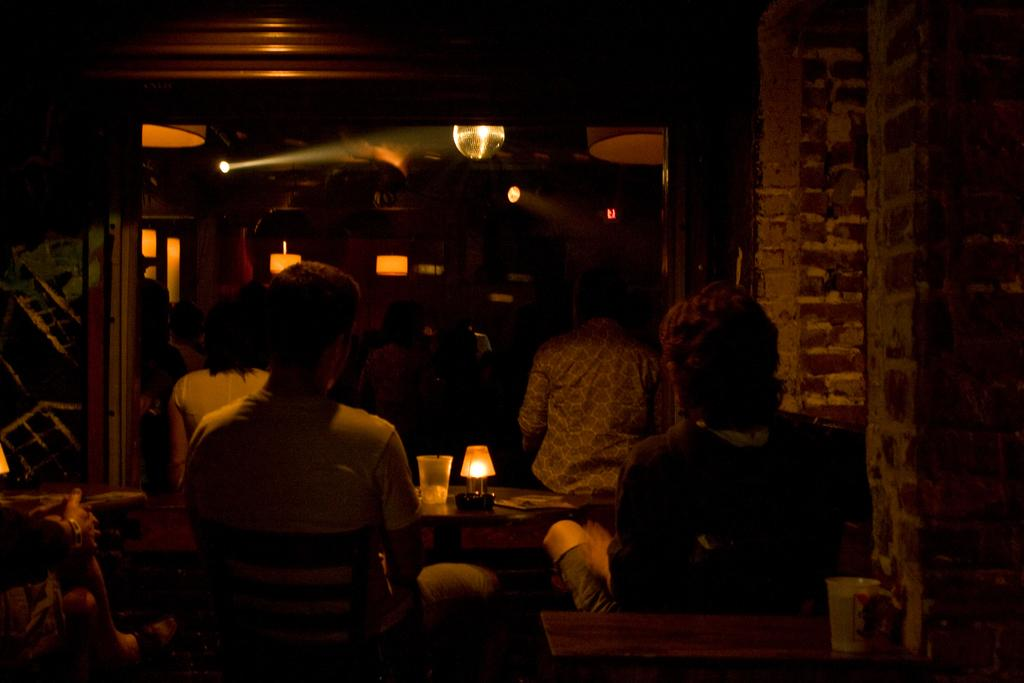How many people are in the image? There are four persons in the image. What object can be seen in the image that provides light? There is a lamp in the image. What object can be seen in the image that is typically used for drinking? There is a glass in the image. What can be said about the background of the image? The background of the image is dark. What type of teaching is happening in the image? There is no teaching activity depicted in the image. Can you see a net in the image? There is no net present in the image. 